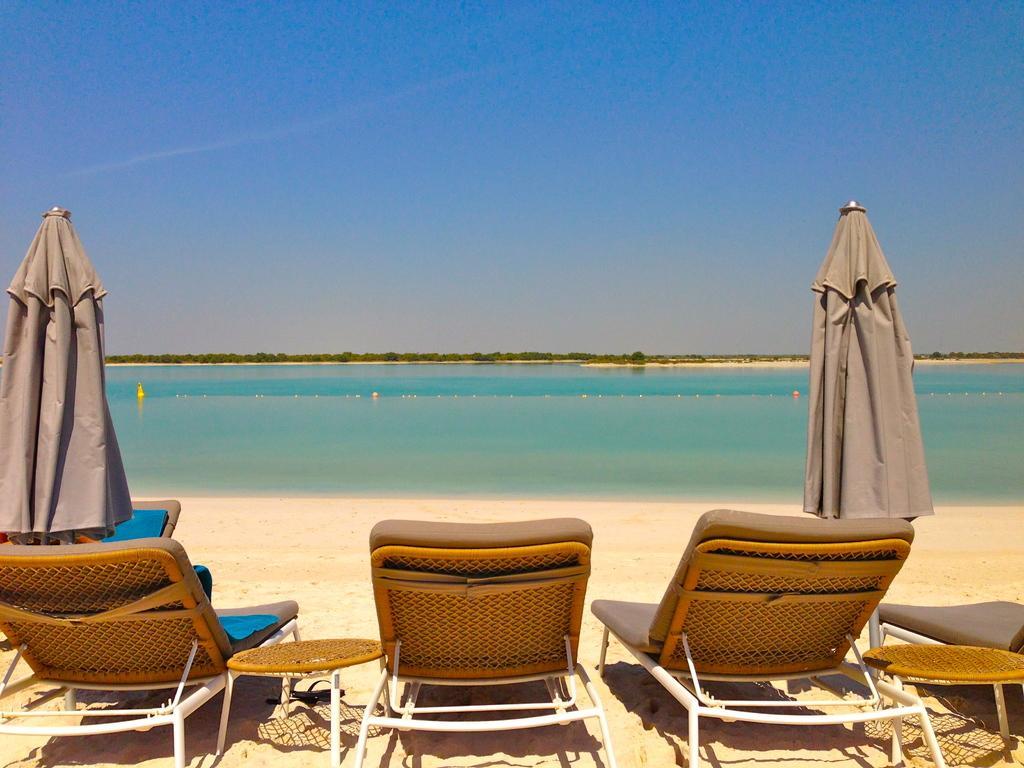Please provide a concise description of this image. At the bottom of the image we can see chaise lounges, stands and parasols. In the background there is a sea and sky. 